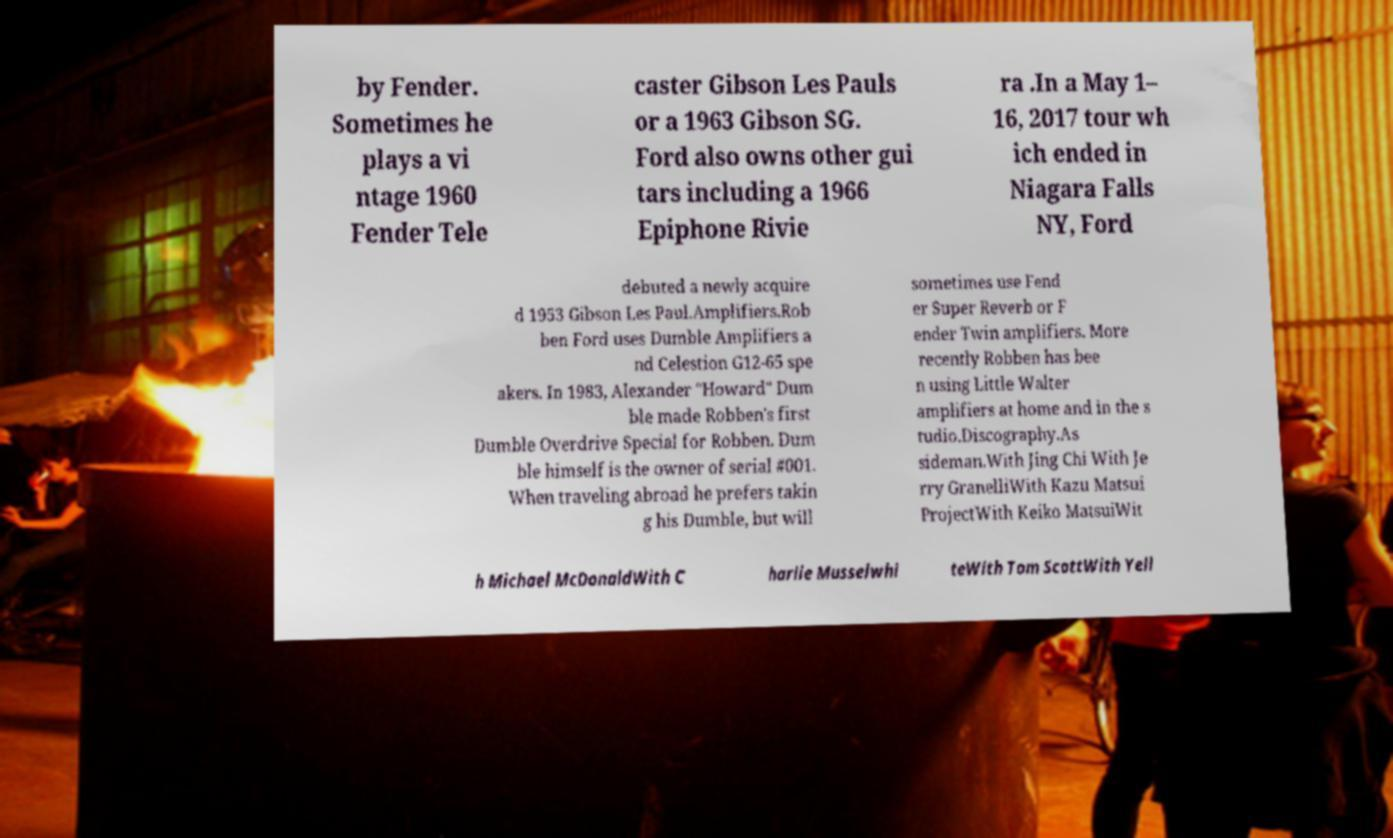For documentation purposes, I need the text within this image transcribed. Could you provide that? by Fender. Sometimes he plays a vi ntage 1960 Fender Tele caster Gibson Les Pauls or a 1963 Gibson SG. Ford also owns other gui tars including a 1966 Epiphone Rivie ra .In a May 1– 16, 2017 tour wh ich ended in Niagara Falls NY, Ford debuted a newly acquire d 1953 Gibson Les Paul.Amplifiers.Rob ben Ford uses Dumble Amplifiers a nd Celestion G12-65 spe akers. In 1983, Alexander "Howard" Dum ble made Robben's first Dumble Overdrive Special for Robben. Dum ble himself is the owner of serial #001. When traveling abroad he prefers takin g his Dumble, but will sometimes use Fend er Super Reverb or F ender Twin amplifiers. More recently Robben has bee n using Little Walter amplifiers at home and in the s tudio.Discography.As sideman.With Jing Chi With Je rry GranelliWith Kazu Matsui ProjectWith Keiko MatsuiWit h Michael McDonaldWith C harlie Musselwhi teWith Tom ScottWith Yell 